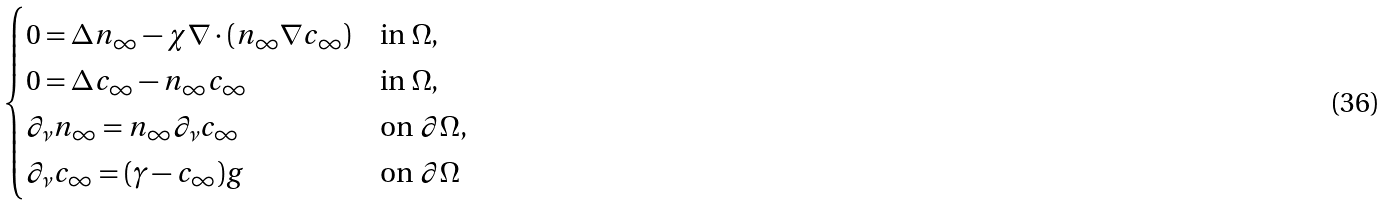<formula> <loc_0><loc_0><loc_500><loc_500>\begin{cases} 0 = \Delta n _ { \infty } - \chi \nabla \cdot ( n _ { \infty } \nabla c _ { \infty } ) & \text {in $\Omega$} , \\ 0 = \Delta c _ { \infty } - n _ { \infty } c _ { \infty } & \text {in $\Omega$} , \\ \partial _ { \nu } n _ { \infty } = n _ { \infty } \partial _ { \nu } c _ { \infty } & \text {on $\partial \Omega$} , \\ \partial _ { \nu } c _ { \infty } = ( \gamma - c _ { \infty } ) g & \text {on $\partial \Omega$} \end{cases}</formula> 